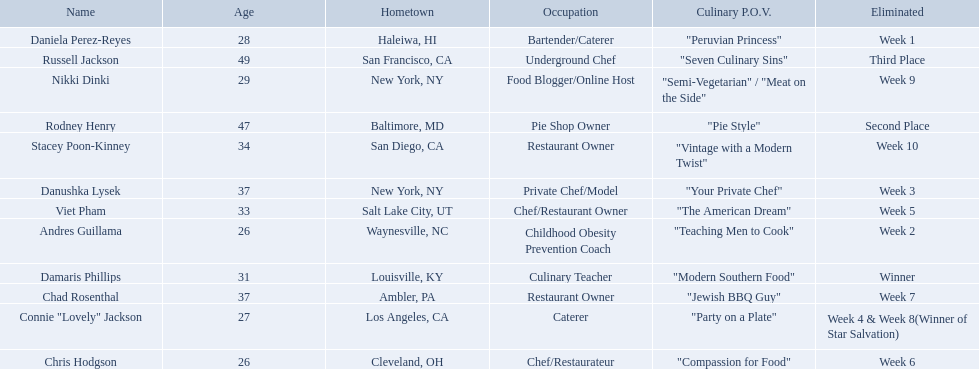Who are all of the contestants? Damaris Phillips, Rodney Henry, Russell Jackson, Stacey Poon-Kinney, Nikki Dinki, Chad Rosenthal, Chris Hodgson, Viet Pham, Connie "Lovely" Jackson, Danushka Lysek, Andres Guillama, Daniela Perez-Reyes. What is each player's culinary point of view? "Modern Southern Food", "Pie Style", "Seven Culinary Sins", "Vintage with a Modern Twist", "Semi-Vegetarian" / "Meat on the Side", "Jewish BBQ Guy", "Compassion for Food", "The American Dream", "Party on a Plate", "Your Private Chef", "Teaching Men to Cook", "Peruvian Princess". And which player's point of view is the longest? Nikki Dinki. 